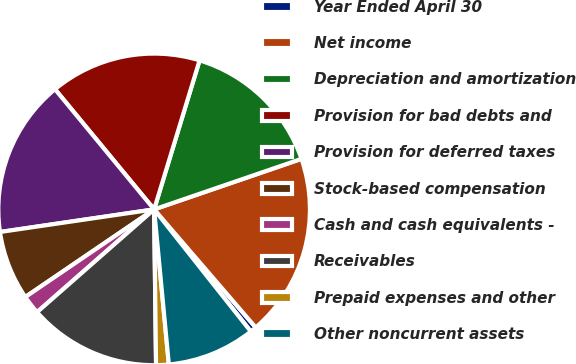Convert chart. <chart><loc_0><loc_0><loc_500><loc_500><pie_chart><fcel>Year Ended April 30<fcel>Net income<fcel>Depreciation and amortization<fcel>Provision for bad debts and<fcel>Provision for deferred taxes<fcel>Stock-based compensation<fcel>Cash and cash equivalents -<fcel>Receivables<fcel>Prepaid expenses and other<fcel>Other noncurrent assets<nl><fcel>0.65%<fcel>18.95%<fcel>15.03%<fcel>15.69%<fcel>16.34%<fcel>7.19%<fcel>1.96%<fcel>13.73%<fcel>1.31%<fcel>9.15%<nl></chart> 